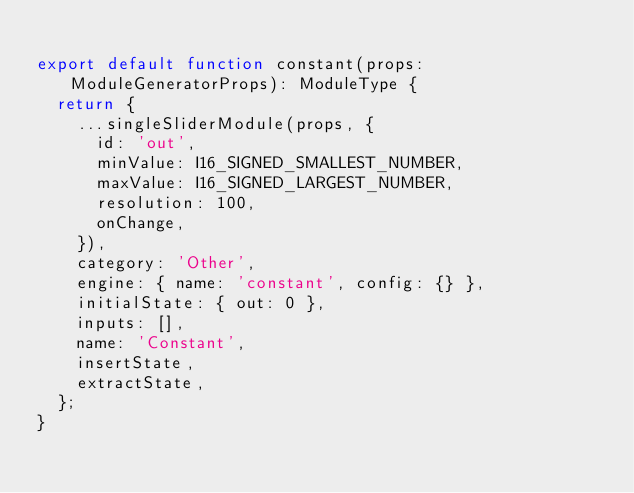<code> <loc_0><loc_0><loc_500><loc_500><_TypeScript_>
export default function constant(props: ModuleGeneratorProps): ModuleType {
	return {
		...singleSliderModule(props, {
			id: 'out',
			minValue: I16_SIGNED_SMALLEST_NUMBER,
			maxValue: I16_SIGNED_LARGEST_NUMBER,
			resolution: 100,
			onChange,
		}),
		category: 'Other',
		engine: { name: 'constant', config: {} },
		initialState: { out: 0 },
		inputs: [],
		name: 'Constant',
		insertState,
		extractState,
	};
}
</code> 